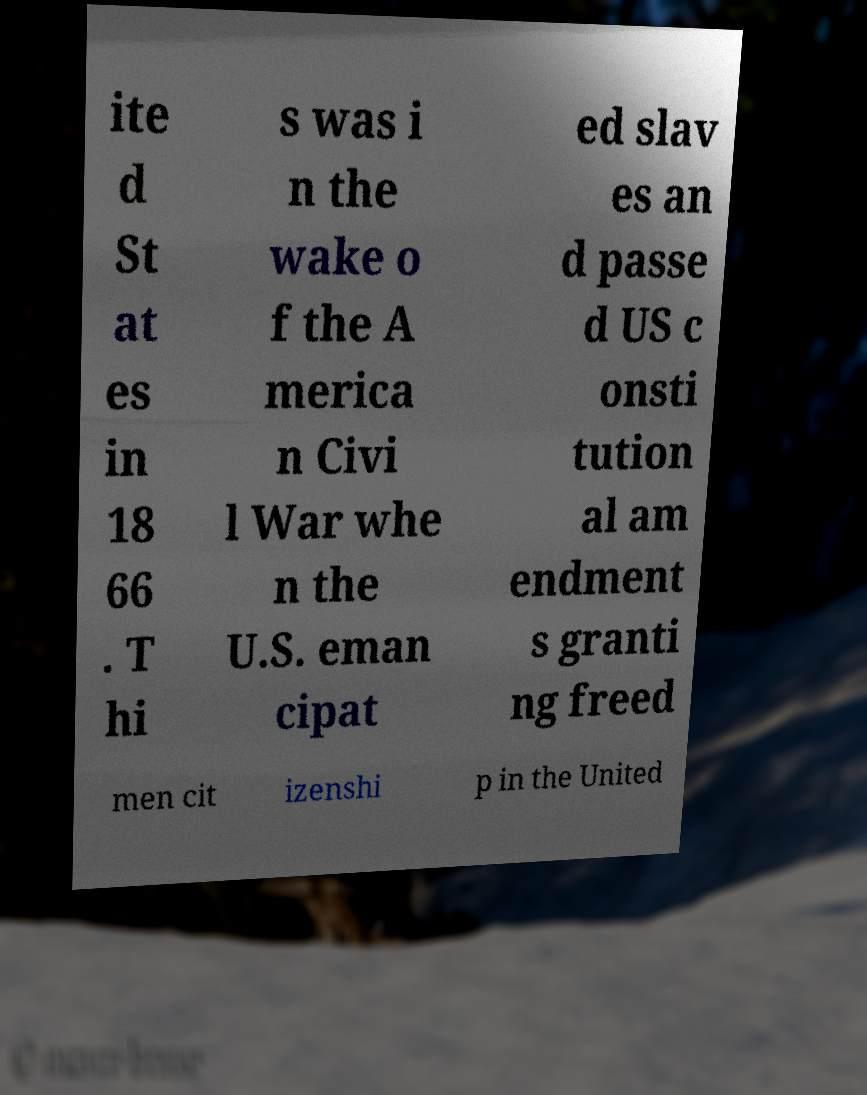Please read and relay the text visible in this image. What does it say? ite d St at es in 18 66 . T hi s was i n the wake o f the A merica n Civi l War whe n the U.S. eman cipat ed slav es an d passe d US c onsti tution al am endment s granti ng freed men cit izenshi p in the United 